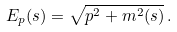<formula> <loc_0><loc_0><loc_500><loc_500>E _ { p } ( s ) = \sqrt { p ^ { 2 } + m ^ { 2 } ( s ) } \, .</formula> 